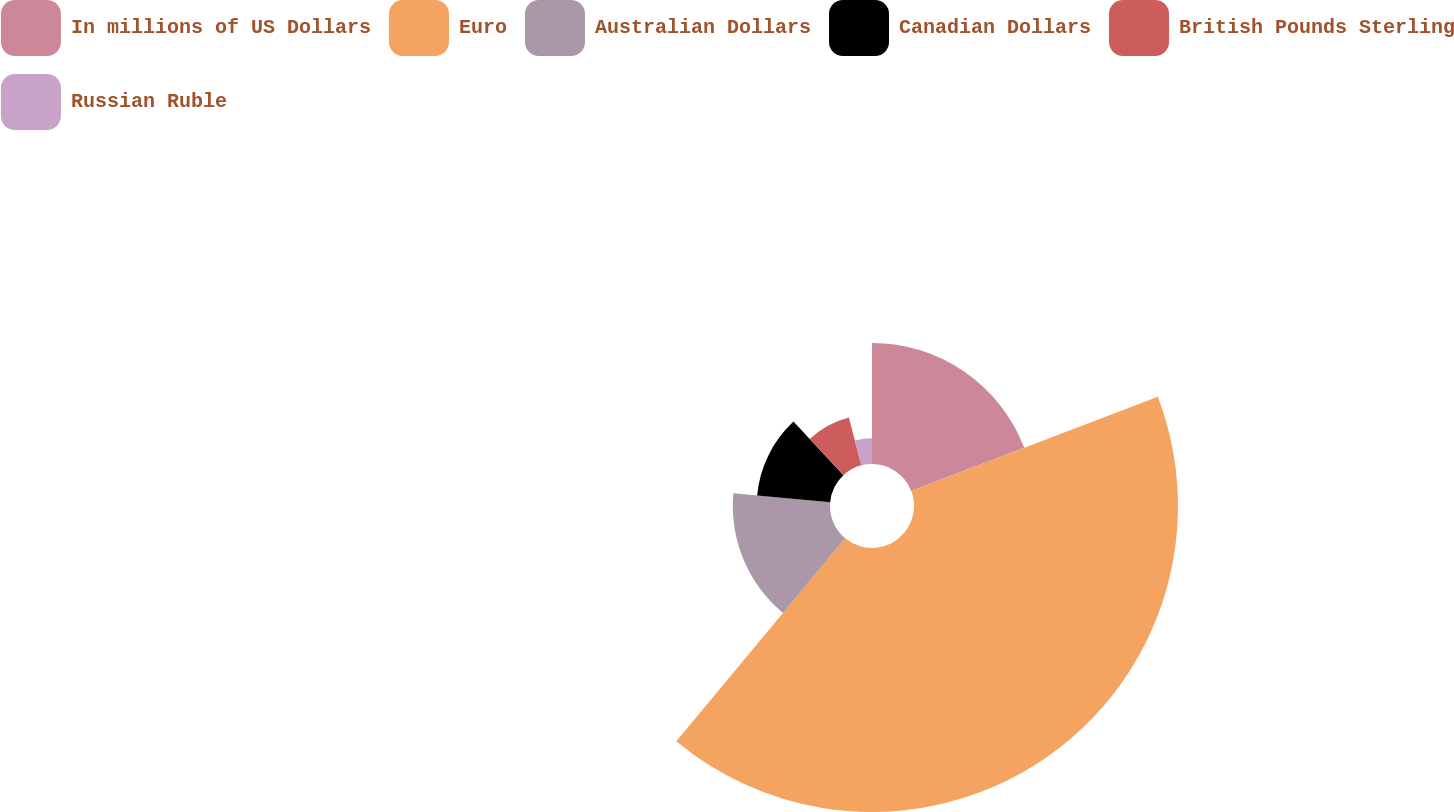Convert chart to OTSL. <chart><loc_0><loc_0><loc_500><loc_500><pie_chart><fcel>In millions of US Dollars<fcel>Euro<fcel>Australian Dollars<fcel>Canadian Dollars<fcel>British Pounds Sterling<fcel>Russian Ruble<nl><fcel>19.19%<fcel>41.86%<fcel>15.41%<fcel>11.63%<fcel>7.85%<fcel>4.07%<nl></chart> 